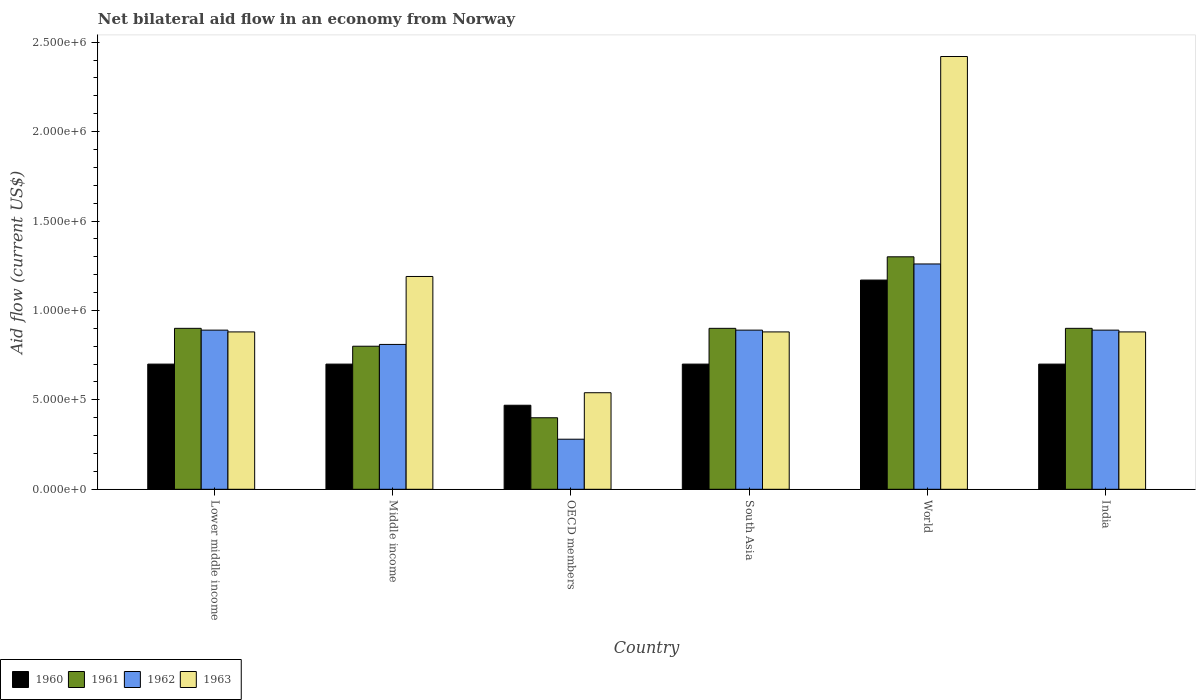How many groups of bars are there?
Keep it short and to the point. 6. How many bars are there on the 6th tick from the left?
Offer a very short reply. 4. What is the label of the 6th group of bars from the left?
Offer a very short reply. India. What is the net bilateral aid flow in 1963 in World?
Make the answer very short. 2.42e+06. Across all countries, what is the maximum net bilateral aid flow in 1962?
Ensure brevity in your answer.  1.26e+06. In which country was the net bilateral aid flow in 1963 maximum?
Your answer should be compact. World. What is the total net bilateral aid flow in 1962 in the graph?
Provide a succinct answer. 5.02e+06. What is the difference between the net bilateral aid flow in 1961 in Middle income and that in OECD members?
Offer a very short reply. 4.00e+05. What is the difference between the net bilateral aid flow in 1960 in OECD members and the net bilateral aid flow in 1962 in Lower middle income?
Your answer should be very brief. -4.20e+05. What is the average net bilateral aid flow in 1962 per country?
Your answer should be compact. 8.37e+05. What is the difference between the net bilateral aid flow of/in 1961 and net bilateral aid flow of/in 1962 in Middle income?
Offer a terse response. -10000. What is the ratio of the net bilateral aid flow in 1963 in Middle income to that in OECD members?
Make the answer very short. 2.2. Is the net bilateral aid flow in 1961 in Lower middle income less than that in South Asia?
Keep it short and to the point. No. What is the difference between the highest and the lowest net bilateral aid flow in 1960?
Ensure brevity in your answer.  7.00e+05. In how many countries, is the net bilateral aid flow in 1961 greater than the average net bilateral aid flow in 1961 taken over all countries?
Keep it short and to the point. 4. Is the sum of the net bilateral aid flow in 1963 in Middle income and South Asia greater than the maximum net bilateral aid flow in 1962 across all countries?
Offer a very short reply. Yes. Is it the case that in every country, the sum of the net bilateral aid flow in 1961 and net bilateral aid flow in 1960 is greater than the sum of net bilateral aid flow in 1962 and net bilateral aid flow in 1963?
Make the answer very short. No. What does the 3rd bar from the left in World represents?
Ensure brevity in your answer.  1962. What does the 1st bar from the right in OECD members represents?
Provide a succinct answer. 1963. Is it the case that in every country, the sum of the net bilateral aid flow in 1962 and net bilateral aid flow in 1960 is greater than the net bilateral aid flow in 1961?
Make the answer very short. Yes. Are all the bars in the graph horizontal?
Ensure brevity in your answer.  No. How many countries are there in the graph?
Ensure brevity in your answer.  6. What is the difference between two consecutive major ticks on the Y-axis?
Offer a very short reply. 5.00e+05. Are the values on the major ticks of Y-axis written in scientific E-notation?
Ensure brevity in your answer.  Yes. Does the graph contain any zero values?
Offer a very short reply. No. Where does the legend appear in the graph?
Provide a succinct answer. Bottom left. How many legend labels are there?
Offer a terse response. 4. What is the title of the graph?
Ensure brevity in your answer.  Net bilateral aid flow in an economy from Norway. What is the label or title of the X-axis?
Provide a succinct answer. Country. What is the Aid flow (current US$) of 1961 in Lower middle income?
Make the answer very short. 9.00e+05. What is the Aid flow (current US$) of 1962 in Lower middle income?
Ensure brevity in your answer.  8.90e+05. What is the Aid flow (current US$) in 1963 in Lower middle income?
Your response must be concise. 8.80e+05. What is the Aid flow (current US$) of 1960 in Middle income?
Give a very brief answer. 7.00e+05. What is the Aid flow (current US$) of 1961 in Middle income?
Provide a short and direct response. 8.00e+05. What is the Aid flow (current US$) in 1962 in Middle income?
Make the answer very short. 8.10e+05. What is the Aid flow (current US$) in 1963 in Middle income?
Offer a terse response. 1.19e+06. What is the Aid flow (current US$) of 1961 in OECD members?
Your response must be concise. 4.00e+05. What is the Aid flow (current US$) in 1963 in OECD members?
Your response must be concise. 5.40e+05. What is the Aid flow (current US$) in 1962 in South Asia?
Your answer should be very brief. 8.90e+05. What is the Aid flow (current US$) in 1963 in South Asia?
Offer a terse response. 8.80e+05. What is the Aid flow (current US$) of 1960 in World?
Keep it short and to the point. 1.17e+06. What is the Aid flow (current US$) of 1961 in World?
Give a very brief answer. 1.30e+06. What is the Aid flow (current US$) of 1962 in World?
Make the answer very short. 1.26e+06. What is the Aid flow (current US$) of 1963 in World?
Provide a short and direct response. 2.42e+06. What is the Aid flow (current US$) of 1962 in India?
Offer a very short reply. 8.90e+05. What is the Aid flow (current US$) in 1963 in India?
Give a very brief answer. 8.80e+05. Across all countries, what is the maximum Aid flow (current US$) of 1960?
Provide a succinct answer. 1.17e+06. Across all countries, what is the maximum Aid flow (current US$) of 1961?
Give a very brief answer. 1.30e+06. Across all countries, what is the maximum Aid flow (current US$) in 1962?
Ensure brevity in your answer.  1.26e+06. Across all countries, what is the maximum Aid flow (current US$) of 1963?
Offer a terse response. 2.42e+06. Across all countries, what is the minimum Aid flow (current US$) of 1962?
Keep it short and to the point. 2.80e+05. Across all countries, what is the minimum Aid flow (current US$) of 1963?
Offer a terse response. 5.40e+05. What is the total Aid flow (current US$) of 1960 in the graph?
Offer a very short reply. 4.44e+06. What is the total Aid flow (current US$) of 1961 in the graph?
Offer a terse response. 5.20e+06. What is the total Aid flow (current US$) of 1962 in the graph?
Make the answer very short. 5.02e+06. What is the total Aid flow (current US$) in 1963 in the graph?
Offer a terse response. 6.79e+06. What is the difference between the Aid flow (current US$) of 1963 in Lower middle income and that in Middle income?
Your response must be concise. -3.10e+05. What is the difference between the Aid flow (current US$) in 1961 in Lower middle income and that in OECD members?
Offer a very short reply. 5.00e+05. What is the difference between the Aid flow (current US$) in 1963 in Lower middle income and that in OECD members?
Your answer should be compact. 3.40e+05. What is the difference between the Aid flow (current US$) of 1960 in Lower middle income and that in South Asia?
Your response must be concise. 0. What is the difference between the Aid flow (current US$) in 1963 in Lower middle income and that in South Asia?
Provide a short and direct response. 0. What is the difference between the Aid flow (current US$) of 1960 in Lower middle income and that in World?
Your answer should be compact. -4.70e+05. What is the difference between the Aid flow (current US$) of 1961 in Lower middle income and that in World?
Your answer should be compact. -4.00e+05. What is the difference between the Aid flow (current US$) of 1962 in Lower middle income and that in World?
Offer a very short reply. -3.70e+05. What is the difference between the Aid flow (current US$) of 1963 in Lower middle income and that in World?
Your response must be concise. -1.54e+06. What is the difference between the Aid flow (current US$) in 1960 in Lower middle income and that in India?
Your response must be concise. 0. What is the difference between the Aid flow (current US$) in 1961 in Lower middle income and that in India?
Give a very brief answer. 0. What is the difference between the Aid flow (current US$) in 1962 in Middle income and that in OECD members?
Ensure brevity in your answer.  5.30e+05. What is the difference between the Aid flow (current US$) in 1963 in Middle income and that in OECD members?
Keep it short and to the point. 6.50e+05. What is the difference between the Aid flow (current US$) of 1961 in Middle income and that in South Asia?
Your answer should be very brief. -1.00e+05. What is the difference between the Aid flow (current US$) in 1960 in Middle income and that in World?
Offer a very short reply. -4.70e+05. What is the difference between the Aid flow (current US$) in 1961 in Middle income and that in World?
Offer a terse response. -5.00e+05. What is the difference between the Aid flow (current US$) of 1962 in Middle income and that in World?
Make the answer very short. -4.50e+05. What is the difference between the Aid flow (current US$) of 1963 in Middle income and that in World?
Offer a terse response. -1.23e+06. What is the difference between the Aid flow (current US$) in 1961 in Middle income and that in India?
Offer a very short reply. -1.00e+05. What is the difference between the Aid flow (current US$) in 1963 in Middle income and that in India?
Keep it short and to the point. 3.10e+05. What is the difference between the Aid flow (current US$) of 1960 in OECD members and that in South Asia?
Make the answer very short. -2.30e+05. What is the difference between the Aid flow (current US$) in 1961 in OECD members and that in South Asia?
Ensure brevity in your answer.  -5.00e+05. What is the difference between the Aid flow (current US$) of 1962 in OECD members and that in South Asia?
Give a very brief answer. -6.10e+05. What is the difference between the Aid flow (current US$) of 1960 in OECD members and that in World?
Your answer should be very brief. -7.00e+05. What is the difference between the Aid flow (current US$) of 1961 in OECD members and that in World?
Offer a very short reply. -9.00e+05. What is the difference between the Aid flow (current US$) of 1962 in OECD members and that in World?
Provide a short and direct response. -9.80e+05. What is the difference between the Aid flow (current US$) in 1963 in OECD members and that in World?
Your answer should be compact. -1.88e+06. What is the difference between the Aid flow (current US$) of 1961 in OECD members and that in India?
Your answer should be very brief. -5.00e+05. What is the difference between the Aid flow (current US$) in 1962 in OECD members and that in India?
Your response must be concise. -6.10e+05. What is the difference between the Aid flow (current US$) of 1960 in South Asia and that in World?
Your response must be concise. -4.70e+05. What is the difference between the Aid flow (current US$) in 1961 in South Asia and that in World?
Offer a terse response. -4.00e+05. What is the difference between the Aid flow (current US$) of 1962 in South Asia and that in World?
Your answer should be compact. -3.70e+05. What is the difference between the Aid flow (current US$) of 1963 in South Asia and that in World?
Your answer should be very brief. -1.54e+06. What is the difference between the Aid flow (current US$) of 1963 in South Asia and that in India?
Ensure brevity in your answer.  0. What is the difference between the Aid flow (current US$) of 1960 in World and that in India?
Keep it short and to the point. 4.70e+05. What is the difference between the Aid flow (current US$) in 1962 in World and that in India?
Offer a very short reply. 3.70e+05. What is the difference between the Aid flow (current US$) in 1963 in World and that in India?
Your answer should be compact. 1.54e+06. What is the difference between the Aid flow (current US$) in 1960 in Lower middle income and the Aid flow (current US$) in 1962 in Middle income?
Ensure brevity in your answer.  -1.10e+05. What is the difference between the Aid flow (current US$) in 1960 in Lower middle income and the Aid flow (current US$) in 1963 in Middle income?
Provide a succinct answer. -4.90e+05. What is the difference between the Aid flow (current US$) of 1962 in Lower middle income and the Aid flow (current US$) of 1963 in Middle income?
Make the answer very short. -3.00e+05. What is the difference between the Aid flow (current US$) of 1960 in Lower middle income and the Aid flow (current US$) of 1963 in OECD members?
Offer a terse response. 1.60e+05. What is the difference between the Aid flow (current US$) in 1961 in Lower middle income and the Aid flow (current US$) in 1962 in OECD members?
Keep it short and to the point. 6.20e+05. What is the difference between the Aid flow (current US$) of 1960 in Lower middle income and the Aid flow (current US$) of 1962 in South Asia?
Your answer should be compact. -1.90e+05. What is the difference between the Aid flow (current US$) in 1961 in Lower middle income and the Aid flow (current US$) in 1962 in South Asia?
Your answer should be very brief. 10000. What is the difference between the Aid flow (current US$) of 1961 in Lower middle income and the Aid flow (current US$) of 1963 in South Asia?
Make the answer very short. 2.00e+04. What is the difference between the Aid flow (current US$) in 1960 in Lower middle income and the Aid flow (current US$) in 1961 in World?
Make the answer very short. -6.00e+05. What is the difference between the Aid flow (current US$) of 1960 in Lower middle income and the Aid flow (current US$) of 1962 in World?
Make the answer very short. -5.60e+05. What is the difference between the Aid flow (current US$) of 1960 in Lower middle income and the Aid flow (current US$) of 1963 in World?
Give a very brief answer. -1.72e+06. What is the difference between the Aid flow (current US$) of 1961 in Lower middle income and the Aid flow (current US$) of 1962 in World?
Give a very brief answer. -3.60e+05. What is the difference between the Aid flow (current US$) of 1961 in Lower middle income and the Aid flow (current US$) of 1963 in World?
Offer a very short reply. -1.52e+06. What is the difference between the Aid flow (current US$) of 1962 in Lower middle income and the Aid flow (current US$) of 1963 in World?
Your response must be concise. -1.53e+06. What is the difference between the Aid flow (current US$) in 1960 in Lower middle income and the Aid flow (current US$) in 1962 in India?
Offer a very short reply. -1.90e+05. What is the difference between the Aid flow (current US$) in 1961 in Lower middle income and the Aid flow (current US$) in 1962 in India?
Your response must be concise. 10000. What is the difference between the Aid flow (current US$) of 1960 in Middle income and the Aid flow (current US$) of 1962 in OECD members?
Offer a very short reply. 4.20e+05. What is the difference between the Aid flow (current US$) in 1961 in Middle income and the Aid flow (current US$) in 1962 in OECD members?
Provide a short and direct response. 5.20e+05. What is the difference between the Aid flow (current US$) of 1961 in Middle income and the Aid flow (current US$) of 1963 in OECD members?
Offer a terse response. 2.60e+05. What is the difference between the Aid flow (current US$) of 1962 in Middle income and the Aid flow (current US$) of 1963 in OECD members?
Your answer should be very brief. 2.70e+05. What is the difference between the Aid flow (current US$) in 1960 in Middle income and the Aid flow (current US$) in 1961 in South Asia?
Your response must be concise. -2.00e+05. What is the difference between the Aid flow (current US$) of 1960 in Middle income and the Aid flow (current US$) of 1962 in South Asia?
Make the answer very short. -1.90e+05. What is the difference between the Aid flow (current US$) of 1961 in Middle income and the Aid flow (current US$) of 1962 in South Asia?
Your answer should be compact. -9.00e+04. What is the difference between the Aid flow (current US$) in 1960 in Middle income and the Aid flow (current US$) in 1961 in World?
Your answer should be very brief. -6.00e+05. What is the difference between the Aid flow (current US$) in 1960 in Middle income and the Aid flow (current US$) in 1962 in World?
Offer a very short reply. -5.60e+05. What is the difference between the Aid flow (current US$) of 1960 in Middle income and the Aid flow (current US$) of 1963 in World?
Make the answer very short. -1.72e+06. What is the difference between the Aid flow (current US$) of 1961 in Middle income and the Aid flow (current US$) of 1962 in World?
Offer a terse response. -4.60e+05. What is the difference between the Aid flow (current US$) in 1961 in Middle income and the Aid flow (current US$) in 1963 in World?
Keep it short and to the point. -1.62e+06. What is the difference between the Aid flow (current US$) of 1962 in Middle income and the Aid flow (current US$) of 1963 in World?
Keep it short and to the point. -1.61e+06. What is the difference between the Aid flow (current US$) of 1960 in Middle income and the Aid flow (current US$) of 1962 in India?
Offer a terse response. -1.90e+05. What is the difference between the Aid flow (current US$) in 1960 in Middle income and the Aid flow (current US$) in 1963 in India?
Offer a terse response. -1.80e+05. What is the difference between the Aid flow (current US$) in 1960 in OECD members and the Aid flow (current US$) in 1961 in South Asia?
Offer a terse response. -4.30e+05. What is the difference between the Aid flow (current US$) of 1960 in OECD members and the Aid flow (current US$) of 1962 in South Asia?
Provide a succinct answer. -4.20e+05. What is the difference between the Aid flow (current US$) of 1960 in OECD members and the Aid flow (current US$) of 1963 in South Asia?
Your answer should be compact. -4.10e+05. What is the difference between the Aid flow (current US$) of 1961 in OECD members and the Aid flow (current US$) of 1962 in South Asia?
Make the answer very short. -4.90e+05. What is the difference between the Aid flow (current US$) of 1961 in OECD members and the Aid flow (current US$) of 1963 in South Asia?
Make the answer very short. -4.80e+05. What is the difference between the Aid flow (current US$) in 1962 in OECD members and the Aid flow (current US$) in 1963 in South Asia?
Your answer should be compact. -6.00e+05. What is the difference between the Aid flow (current US$) of 1960 in OECD members and the Aid flow (current US$) of 1961 in World?
Your answer should be compact. -8.30e+05. What is the difference between the Aid flow (current US$) in 1960 in OECD members and the Aid flow (current US$) in 1962 in World?
Ensure brevity in your answer.  -7.90e+05. What is the difference between the Aid flow (current US$) of 1960 in OECD members and the Aid flow (current US$) of 1963 in World?
Your answer should be very brief. -1.95e+06. What is the difference between the Aid flow (current US$) in 1961 in OECD members and the Aid flow (current US$) in 1962 in World?
Give a very brief answer. -8.60e+05. What is the difference between the Aid flow (current US$) in 1961 in OECD members and the Aid flow (current US$) in 1963 in World?
Offer a very short reply. -2.02e+06. What is the difference between the Aid flow (current US$) in 1962 in OECD members and the Aid flow (current US$) in 1963 in World?
Provide a succinct answer. -2.14e+06. What is the difference between the Aid flow (current US$) in 1960 in OECD members and the Aid flow (current US$) in 1961 in India?
Provide a short and direct response. -4.30e+05. What is the difference between the Aid flow (current US$) of 1960 in OECD members and the Aid flow (current US$) of 1962 in India?
Give a very brief answer. -4.20e+05. What is the difference between the Aid flow (current US$) in 1960 in OECD members and the Aid flow (current US$) in 1963 in India?
Ensure brevity in your answer.  -4.10e+05. What is the difference between the Aid flow (current US$) of 1961 in OECD members and the Aid flow (current US$) of 1962 in India?
Your answer should be compact. -4.90e+05. What is the difference between the Aid flow (current US$) in 1961 in OECD members and the Aid flow (current US$) in 1963 in India?
Give a very brief answer. -4.80e+05. What is the difference between the Aid flow (current US$) in 1962 in OECD members and the Aid flow (current US$) in 1963 in India?
Offer a very short reply. -6.00e+05. What is the difference between the Aid flow (current US$) in 1960 in South Asia and the Aid flow (current US$) in 1961 in World?
Provide a short and direct response. -6.00e+05. What is the difference between the Aid flow (current US$) in 1960 in South Asia and the Aid flow (current US$) in 1962 in World?
Give a very brief answer. -5.60e+05. What is the difference between the Aid flow (current US$) of 1960 in South Asia and the Aid flow (current US$) of 1963 in World?
Your answer should be very brief. -1.72e+06. What is the difference between the Aid flow (current US$) in 1961 in South Asia and the Aid flow (current US$) in 1962 in World?
Your response must be concise. -3.60e+05. What is the difference between the Aid flow (current US$) in 1961 in South Asia and the Aid flow (current US$) in 1963 in World?
Give a very brief answer. -1.52e+06. What is the difference between the Aid flow (current US$) in 1962 in South Asia and the Aid flow (current US$) in 1963 in World?
Ensure brevity in your answer.  -1.53e+06. What is the difference between the Aid flow (current US$) in 1960 in South Asia and the Aid flow (current US$) in 1962 in India?
Make the answer very short. -1.90e+05. What is the difference between the Aid flow (current US$) of 1960 in South Asia and the Aid flow (current US$) of 1963 in India?
Your answer should be very brief. -1.80e+05. What is the difference between the Aid flow (current US$) of 1961 in South Asia and the Aid flow (current US$) of 1963 in India?
Offer a terse response. 2.00e+04. What is the difference between the Aid flow (current US$) in 1960 in World and the Aid flow (current US$) in 1962 in India?
Your answer should be compact. 2.80e+05. What is the difference between the Aid flow (current US$) in 1960 in World and the Aid flow (current US$) in 1963 in India?
Provide a short and direct response. 2.90e+05. What is the difference between the Aid flow (current US$) of 1962 in World and the Aid flow (current US$) of 1963 in India?
Make the answer very short. 3.80e+05. What is the average Aid flow (current US$) of 1960 per country?
Offer a terse response. 7.40e+05. What is the average Aid flow (current US$) in 1961 per country?
Keep it short and to the point. 8.67e+05. What is the average Aid flow (current US$) in 1962 per country?
Your response must be concise. 8.37e+05. What is the average Aid flow (current US$) of 1963 per country?
Ensure brevity in your answer.  1.13e+06. What is the difference between the Aid flow (current US$) of 1961 and Aid flow (current US$) of 1962 in Lower middle income?
Keep it short and to the point. 10000. What is the difference between the Aid flow (current US$) of 1960 and Aid flow (current US$) of 1962 in Middle income?
Your answer should be compact. -1.10e+05. What is the difference between the Aid flow (current US$) in 1960 and Aid flow (current US$) in 1963 in Middle income?
Give a very brief answer. -4.90e+05. What is the difference between the Aid flow (current US$) of 1961 and Aid flow (current US$) of 1962 in Middle income?
Make the answer very short. -10000. What is the difference between the Aid flow (current US$) in 1961 and Aid flow (current US$) in 1963 in Middle income?
Your answer should be very brief. -3.90e+05. What is the difference between the Aid flow (current US$) in 1962 and Aid flow (current US$) in 1963 in Middle income?
Your answer should be very brief. -3.80e+05. What is the difference between the Aid flow (current US$) of 1960 and Aid flow (current US$) of 1961 in OECD members?
Provide a short and direct response. 7.00e+04. What is the difference between the Aid flow (current US$) of 1960 and Aid flow (current US$) of 1962 in OECD members?
Offer a very short reply. 1.90e+05. What is the difference between the Aid flow (current US$) of 1961 and Aid flow (current US$) of 1962 in OECD members?
Offer a terse response. 1.20e+05. What is the difference between the Aid flow (current US$) in 1961 and Aid flow (current US$) in 1963 in South Asia?
Make the answer very short. 2.00e+04. What is the difference between the Aid flow (current US$) in 1960 and Aid flow (current US$) in 1961 in World?
Offer a very short reply. -1.30e+05. What is the difference between the Aid flow (current US$) of 1960 and Aid flow (current US$) of 1962 in World?
Your response must be concise. -9.00e+04. What is the difference between the Aid flow (current US$) of 1960 and Aid flow (current US$) of 1963 in World?
Your answer should be compact. -1.25e+06. What is the difference between the Aid flow (current US$) of 1961 and Aid flow (current US$) of 1962 in World?
Give a very brief answer. 4.00e+04. What is the difference between the Aid flow (current US$) in 1961 and Aid flow (current US$) in 1963 in World?
Your answer should be compact. -1.12e+06. What is the difference between the Aid flow (current US$) in 1962 and Aid flow (current US$) in 1963 in World?
Provide a short and direct response. -1.16e+06. What is the difference between the Aid flow (current US$) of 1960 and Aid flow (current US$) of 1961 in India?
Your answer should be very brief. -2.00e+05. What is the difference between the Aid flow (current US$) in 1960 and Aid flow (current US$) in 1963 in India?
Provide a short and direct response. -1.80e+05. What is the difference between the Aid flow (current US$) in 1961 and Aid flow (current US$) in 1963 in India?
Give a very brief answer. 2.00e+04. What is the ratio of the Aid flow (current US$) in 1961 in Lower middle income to that in Middle income?
Offer a very short reply. 1.12. What is the ratio of the Aid flow (current US$) in 1962 in Lower middle income to that in Middle income?
Offer a terse response. 1.1. What is the ratio of the Aid flow (current US$) of 1963 in Lower middle income to that in Middle income?
Your answer should be compact. 0.74. What is the ratio of the Aid flow (current US$) of 1960 in Lower middle income to that in OECD members?
Your answer should be compact. 1.49. What is the ratio of the Aid flow (current US$) of 1961 in Lower middle income to that in OECD members?
Offer a very short reply. 2.25. What is the ratio of the Aid flow (current US$) of 1962 in Lower middle income to that in OECD members?
Ensure brevity in your answer.  3.18. What is the ratio of the Aid flow (current US$) of 1963 in Lower middle income to that in OECD members?
Offer a terse response. 1.63. What is the ratio of the Aid flow (current US$) in 1961 in Lower middle income to that in South Asia?
Give a very brief answer. 1. What is the ratio of the Aid flow (current US$) of 1962 in Lower middle income to that in South Asia?
Ensure brevity in your answer.  1. What is the ratio of the Aid flow (current US$) of 1963 in Lower middle income to that in South Asia?
Provide a short and direct response. 1. What is the ratio of the Aid flow (current US$) of 1960 in Lower middle income to that in World?
Give a very brief answer. 0.6. What is the ratio of the Aid flow (current US$) in 1961 in Lower middle income to that in World?
Make the answer very short. 0.69. What is the ratio of the Aid flow (current US$) of 1962 in Lower middle income to that in World?
Your answer should be compact. 0.71. What is the ratio of the Aid flow (current US$) in 1963 in Lower middle income to that in World?
Your answer should be very brief. 0.36. What is the ratio of the Aid flow (current US$) of 1962 in Lower middle income to that in India?
Ensure brevity in your answer.  1. What is the ratio of the Aid flow (current US$) in 1960 in Middle income to that in OECD members?
Your response must be concise. 1.49. What is the ratio of the Aid flow (current US$) of 1962 in Middle income to that in OECD members?
Offer a very short reply. 2.89. What is the ratio of the Aid flow (current US$) of 1963 in Middle income to that in OECD members?
Your response must be concise. 2.2. What is the ratio of the Aid flow (current US$) in 1960 in Middle income to that in South Asia?
Offer a terse response. 1. What is the ratio of the Aid flow (current US$) of 1962 in Middle income to that in South Asia?
Provide a short and direct response. 0.91. What is the ratio of the Aid flow (current US$) of 1963 in Middle income to that in South Asia?
Provide a short and direct response. 1.35. What is the ratio of the Aid flow (current US$) in 1960 in Middle income to that in World?
Your answer should be compact. 0.6. What is the ratio of the Aid flow (current US$) in 1961 in Middle income to that in World?
Your response must be concise. 0.62. What is the ratio of the Aid flow (current US$) of 1962 in Middle income to that in World?
Offer a terse response. 0.64. What is the ratio of the Aid flow (current US$) of 1963 in Middle income to that in World?
Provide a succinct answer. 0.49. What is the ratio of the Aid flow (current US$) of 1961 in Middle income to that in India?
Make the answer very short. 0.89. What is the ratio of the Aid flow (current US$) in 1962 in Middle income to that in India?
Your answer should be very brief. 0.91. What is the ratio of the Aid flow (current US$) in 1963 in Middle income to that in India?
Keep it short and to the point. 1.35. What is the ratio of the Aid flow (current US$) in 1960 in OECD members to that in South Asia?
Your response must be concise. 0.67. What is the ratio of the Aid flow (current US$) in 1961 in OECD members to that in South Asia?
Your response must be concise. 0.44. What is the ratio of the Aid flow (current US$) of 1962 in OECD members to that in South Asia?
Your response must be concise. 0.31. What is the ratio of the Aid flow (current US$) in 1963 in OECD members to that in South Asia?
Provide a succinct answer. 0.61. What is the ratio of the Aid flow (current US$) in 1960 in OECD members to that in World?
Provide a succinct answer. 0.4. What is the ratio of the Aid flow (current US$) of 1961 in OECD members to that in World?
Offer a terse response. 0.31. What is the ratio of the Aid flow (current US$) in 1962 in OECD members to that in World?
Make the answer very short. 0.22. What is the ratio of the Aid flow (current US$) of 1963 in OECD members to that in World?
Offer a very short reply. 0.22. What is the ratio of the Aid flow (current US$) in 1960 in OECD members to that in India?
Keep it short and to the point. 0.67. What is the ratio of the Aid flow (current US$) in 1961 in OECD members to that in India?
Give a very brief answer. 0.44. What is the ratio of the Aid flow (current US$) of 1962 in OECD members to that in India?
Your answer should be very brief. 0.31. What is the ratio of the Aid flow (current US$) in 1963 in OECD members to that in India?
Provide a succinct answer. 0.61. What is the ratio of the Aid flow (current US$) of 1960 in South Asia to that in World?
Provide a short and direct response. 0.6. What is the ratio of the Aid flow (current US$) of 1961 in South Asia to that in World?
Keep it short and to the point. 0.69. What is the ratio of the Aid flow (current US$) of 1962 in South Asia to that in World?
Make the answer very short. 0.71. What is the ratio of the Aid flow (current US$) in 1963 in South Asia to that in World?
Give a very brief answer. 0.36. What is the ratio of the Aid flow (current US$) in 1960 in South Asia to that in India?
Provide a short and direct response. 1. What is the ratio of the Aid flow (current US$) in 1961 in South Asia to that in India?
Your answer should be compact. 1. What is the ratio of the Aid flow (current US$) of 1962 in South Asia to that in India?
Your answer should be very brief. 1. What is the ratio of the Aid flow (current US$) in 1960 in World to that in India?
Keep it short and to the point. 1.67. What is the ratio of the Aid flow (current US$) in 1961 in World to that in India?
Provide a succinct answer. 1.44. What is the ratio of the Aid flow (current US$) of 1962 in World to that in India?
Ensure brevity in your answer.  1.42. What is the ratio of the Aid flow (current US$) of 1963 in World to that in India?
Offer a terse response. 2.75. What is the difference between the highest and the second highest Aid flow (current US$) in 1960?
Your response must be concise. 4.70e+05. What is the difference between the highest and the second highest Aid flow (current US$) in 1963?
Provide a short and direct response. 1.23e+06. What is the difference between the highest and the lowest Aid flow (current US$) in 1960?
Offer a terse response. 7.00e+05. What is the difference between the highest and the lowest Aid flow (current US$) in 1961?
Ensure brevity in your answer.  9.00e+05. What is the difference between the highest and the lowest Aid flow (current US$) in 1962?
Offer a very short reply. 9.80e+05. What is the difference between the highest and the lowest Aid flow (current US$) of 1963?
Your answer should be compact. 1.88e+06. 